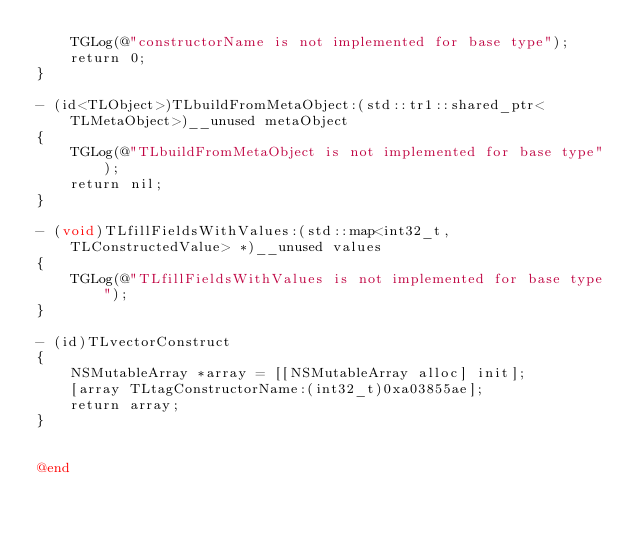Convert code to text. <code><loc_0><loc_0><loc_500><loc_500><_ObjectiveC_>    TGLog(@"constructorName is not implemented for base type");
    return 0;
}

- (id<TLObject>)TLbuildFromMetaObject:(std::tr1::shared_ptr<TLMetaObject>)__unused metaObject
{
    TGLog(@"TLbuildFromMetaObject is not implemented for base type");
    return nil;
}

- (void)TLfillFieldsWithValues:(std::map<int32_t, TLConstructedValue> *)__unused values
{
    TGLog(@"TLfillFieldsWithValues is not implemented for base type");
}

- (id)TLvectorConstruct
{
    NSMutableArray *array = [[NSMutableArray alloc] init];
    [array TLtagConstructorName:(int32_t)0xa03855ae];
    return array;
}


@end

</code> 